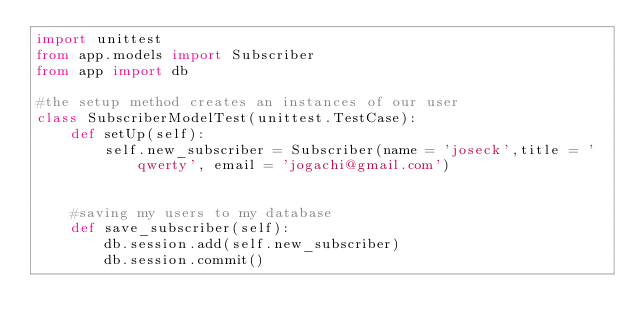Convert code to text. <code><loc_0><loc_0><loc_500><loc_500><_Python_>import unittest
from app.models import Subscriber
from app import db

#the setup method creates an instances of our user
class SubscriberModelTest(unittest.TestCase):
    def setUp(self):
        self.new_subscriber = Subscriber(name = 'joseck',title = 'qwerty', email = 'jogachi@gmail.com')


    #saving my users to my database
    def save_subscriber(self):
        db.session.add(self.new_subscriber)
        db.session.commit()
</code> 